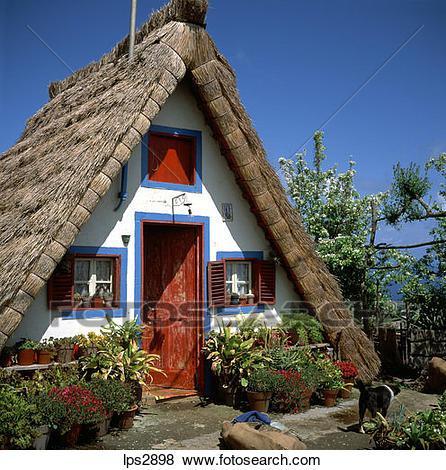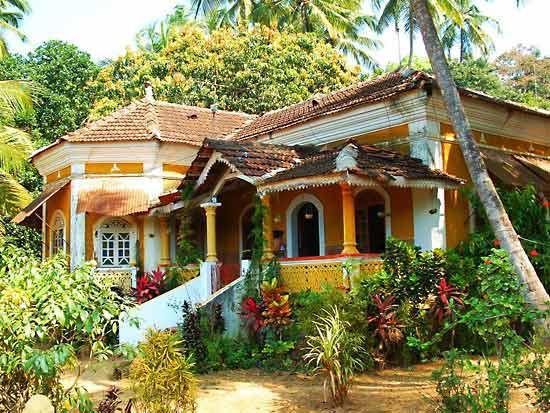The first image is the image on the left, the second image is the image on the right. Considering the images on both sides, is "The right image includes rustic curving walls made of stones of varying shapes." valid? Answer yes or no. No. The first image is the image on the left, the second image is the image on the right. For the images displayed, is the sentence "There are chairs outside." factually correct? Answer yes or no. No. 